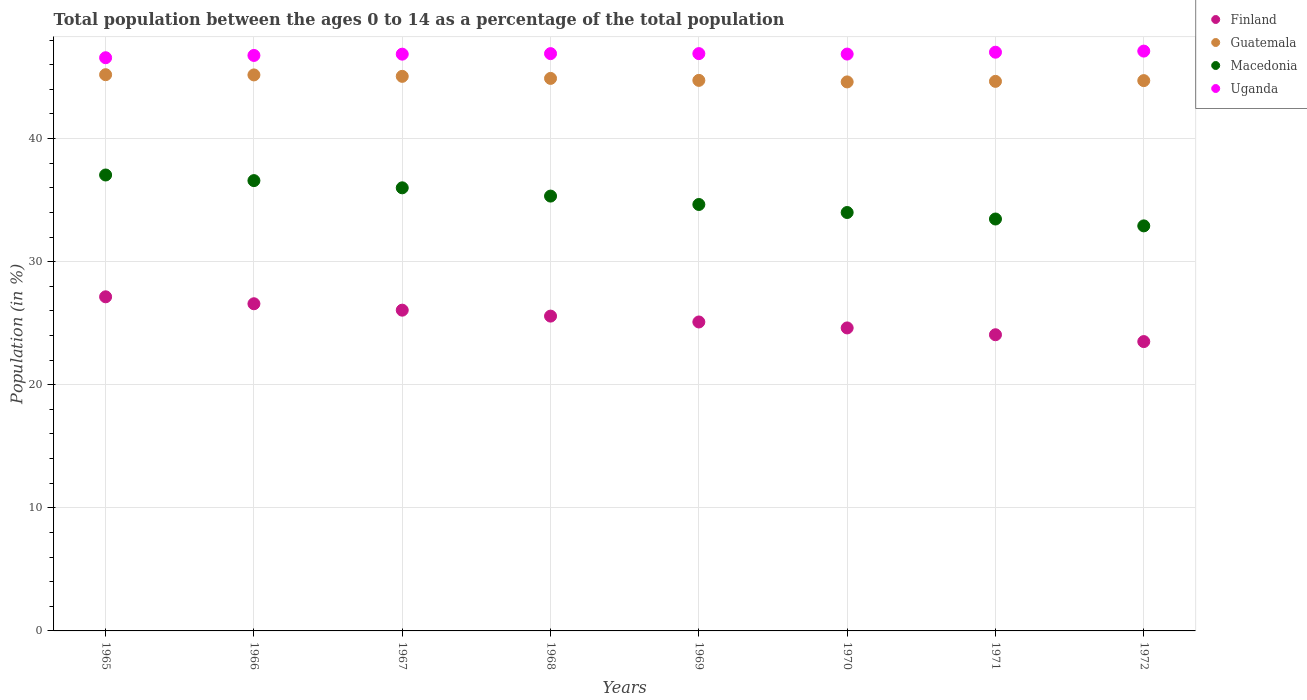How many different coloured dotlines are there?
Make the answer very short. 4. Is the number of dotlines equal to the number of legend labels?
Offer a very short reply. Yes. What is the percentage of the population ages 0 to 14 in Guatemala in 1971?
Offer a terse response. 44.65. Across all years, what is the maximum percentage of the population ages 0 to 14 in Uganda?
Your answer should be very brief. 47.11. Across all years, what is the minimum percentage of the population ages 0 to 14 in Macedonia?
Your answer should be compact. 32.91. In which year was the percentage of the population ages 0 to 14 in Guatemala maximum?
Your answer should be very brief. 1965. What is the total percentage of the population ages 0 to 14 in Guatemala in the graph?
Offer a terse response. 359.01. What is the difference between the percentage of the population ages 0 to 14 in Uganda in 1968 and that in 1972?
Provide a short and direct response. -0.21. What is the difference between the percentage of the population ages 0 to 14 in Macedonia in 1969 and the percentage of the population ages 0 to 14 in Guatemala in 1967?
Your answer should be very brief. -10.41. What is the average percentage of the population ages 0 to 14 in Finland per year?
Keep it short and to the point. 25.33. In the year 1971, what is the difference between the percentage of the population ages 0 to 14 in Macedonia and percentage of the population ages 0 to 14 in Finland?
Offer a very short reply. 9.4. What is the ratio of the percentage of the population ages 0 to 14 in Guatemala in 1970 to that in 1972?
Offer a terse response. 1. Is the percentage of the population ages 0 to 14 in Guatemala in 1969 less than that in 1970?
Your answer should be compact. No. What is the difference between the highest and the second highest percentage of the population ages 0 to 14 in Finland?
Offer a terse response. 0.56. What is the difference between the highest and the lowest percentage of the population ages 0 to 14 in Guatemala?
Your answer should be compact. 0.59. In how many years, is the percentage of the population ages 0 to 14 in Finland greater than the average percentage of the population ages 0 to 14 in Finland taken over all years?
Make the answer very short. 4. Is it the case that in every year, the sum of the percentage of the population ages 0 to 14 in Guatemala and percentage of the population ages 0 to 14 in Uganda  is greater than the sum of percentage of the population ages 0 to 14 in Macedonia and percentage of the population ages 0 to 14 in Finland?
Your response must be concise. Yes. Is it the case that in every year, the sum of the percentage of the population ages 0 to 14 in Macedonia and percentage of the population ages 0 to 14 in Uganda  is greater than the percentage of the population ages 0 to 14 in Guatemala?
Offer a very short reply. Yes. Does the percentage of the population ages 0 to 14 in Guatemala monotonically increase over the years?
Your answer should be compact. No. Is the percentage of the population ages 0 to 14 in Guatemala strictly greater than the percentage of the population ages 0 to 14 in Macedonia over the years?
Your answer should be compact. Yes. Is the percentage of the population ages 0 to 14 in Finland strictly less than the percentage of the population ages 0 to 14 in Macedonia over the years?
Give a very brief answer. Yes. Does the graph contain any zero values?
Your answer should be compact. No. Does the graph contain grids?
Make the answer very short. Yes. What is the title of the graph?
Make the answer very short. Total population between the ages 0 to 14 as a percentage of the total population. Does "Argentina" appear as one of the legend labels in the graph?
Offer a very short reply. No. What is the label or title of the X-axis?
Ensure brevity in your answer.  Years. What is the Population (in %) of Finland in 1965?
Offer a terse response. 27.15. What is the Population (in %) of Guatemala in 1965?
Keep it short and to the point. 45.19. What is the Population (in %) in Macedonia in 1965?
Your answer should be compact. 37.04. What is the Population (in %) of Uganda in 1965?
Make the answer very short. 46.57. What is the Population (in %) of Finland in 1966?
Keep it short and to the point. 26.58. What is the Population (in %) of Guatemala in 1966?
Provide a succinct answer. 45.17. What is the Population (in %) of Macedonia in 1966?
Offer a very short reply. 36.59. What is the Population (in %) of Uganda in 1966?
Make the answer very short. 46.76. What is the Population (in %) in Finland in 1967?
Provide a short and direct response. 26.06. What is the Population (in %) of Guatemala in 1967?
Offer a terse response. 45.06. What is the Population (in %) in Macedonia in 1967?
Offer a very short reply. 36. What is the Population (in %) in Uganda in 1967?
Make the answer very short. 46.86. What is the Population (in %) of Finland in 1968?
Offer a very short reply. 25.58. What is the Population (in %) in Guatemala in 1968?
Your response must be concise. 44.89. What is the Population (in %) of Macedonia in 1968?
Make the answer very short. 35.33. What is the Population (in %) in Uganda in 1968?
Give a very brief answer. 46.9. What is the Population (in %) in Finland in 1969?
Offer a very short reply. 25.1. What is the Population (in %) of Guatemala in 1969?
Ensure brevity in your answer.  44.73. What is the Population (in %) of Macedonia in 1969?
Make the answer very short. 34.65. What is the Population (in %) of Uganda in 1969?
Your answer should be compact. 46.9. What is the Population (in %) of Finland in 1970?
Your response must be concise. 24.62. What is the Population (in %) in Guatemala in 1970?
Ensure brevity in your answer.  44.6. What is the Population (in %) in Macedonia in 1970?
Your answer should be very brief. 33.99. What is the Population (in %) of Uganda in 1970?
Provide a short and direct response. 46.87. What is the Population (in %) in Finland in 1971?
Provide a succinct answer. 24.06. What is the Population (in %) of Guatemala in 1971?
Keep it short and to the point. 44.65. What is the Population (in %) in Macedonia in 1971?
Your response must be concise. 33.47. What is the Population (in %) of Uganda in 1971?
Keep it short and to the point. 47.02. What is the Population (in %) of Finland in 1972?
Keep it short and to the point. 23.51. What is the Population (in %) of Guatemala in 1972?
Give a very brief answer. 44.71. What is the Population (in %) in Macedonia in 1972?
Keep it short and to the point. 32.91. What is the Population (in %) of Uganda in 1972?
Your answer should be very brief. 47.11. Across all years, what is the maximum Population (in %) of Finland?
Ensure brevity in your answer.  27.15. Across all years, what is the maximum Population (in %) in Guatemala?
Offer a very short reply. 45.19. Across all years, what is the maximum Population (in %) in Macedonia?
Keep it short and to the point. 37.04. Across all years, what is the maximum Population (in %) in Uganda?
Make the answer very short. 47.11. Across all years, what is the minimum Population (in %) of Finland?
Your response must be concise. 23.51. Across all years, what is the minimum Population (in %) in Guatemala?
Offer a terse response. 44.6. Across all years, what is the minimum Population (in %) of Macedonia?
Give a very brief answer. 32.91. Across all years, what is the minimum Population (in %) in Uganda?
Offer a terse response. 46.57. What is the total Population (in %) of Finland in the graph?
Keep it short and to the point. 202.65. What is the total Population (in %) of Guatemala in the graph?
Your answer should be very brief. 359.01. What is the total Population (in %) of Macedonia in the graph?
Give a very brief answer. 279.97. What is the total Population (in %) of Uganda in the graph?
Give a very brief answer. 374.99. What is the difference between the Population (in %) in Finland in 1965 and that in 1966?
Give a very brief answer. 0.56. What is the difference between the Population (in %) in Guatemala in 1965 and that in 1966?
Your response must be concise. 0.02. What is the difference between the Population (in %) in Macedonia in 1965 and that in 1966?
Offer a terse response. 0.46. What is the difference between the Population (in %) of Uganda in 1965 and that in 1966?
Your response must be concise. -0.19. What is the difference between the Population (in %) of Finland in 1965 and that in 1967?
Your answer should be compact. 1.09. What is the difference between the Population (in %) in Guatemala in 1965 and that in 1967?
Ensure brevity in your answer.  0.13. What is the difference between the Population (in %) of Macedonia in 1965 and that in 1967?
Ensure brevity in your answer.  1.04. What is the difference between the Population (in %) in Uganda in 1965 and that in 1967?
Offer a very short reply. -0.29. What is the difference between the Population (in %) in Finland in 1965 and that in 1968?
Provide a short and direct response. 1.57. What is the difference between the Population (in %) of Guatemala in 1965 and that in 1968?
Your answer should be very brief. 0.3. What is the difference between the Population (in %) of Macedonia in 1965 and that in 1968?
Offer a very short reply. 1.71. What is the difference between the Population (in %) in Uganda in 1965 and that in 1968?
Your answer should be compact. -0.33. What is the difference between the Population (in %) in Finland in 1965 and that in 1969?
Make the answer very short. 2.04. What is the difference between the Population (in %) in Guatemala in 1965 and that in 1969?
Your answer should be very brief. 0.46. What is the difference between the Population (in %) in Macedonia in 1965 and that in 1969?
Provide a short and direct response. 2.4. What is the difference between the Population (in %) in Uganda in 1965 and that in 1969?
Your response must be concise. -0.33. What is the difference between the Population (in %) of Finland in 1965 and that in 1970?
Make the answer very short. 2.53. What is the difference between the Population (in %) of Guatemala in 1965 and that in 1970?
Provide a succinct answer. 0.59. What is the difference between the Population (in %) of Macedonia in 1965 and that in 1970?
Offer a very short reply. 3.05. What is the difference between the Population (in %) of Uganda in 1965 and that in 1970?
Provide a short and direct response. -0.3. What is the difference between the Population (in %) of Finland in 1965 and that in 1971?
Offer a terse response. 3.08. What is the difference between the Population (in %) in Guatemala in 1965 and that in 1971?
Your answer should be very brief. 0.54. What is the difference between the Population (in %) of Macedonia in 1965 and that in 1971?
Your response must be concise. 3.58. What is the difference between the Population (in %) of Uganda in 1965 and that in 1971?
Give a very brief answer. -0.45. What is the difference between the Population (in %) in Finland in 1965 and that in 1972?
Your answer should be compact. 3.64. What is the difference between the Population (in %) in Guatemala in 1965 and that in 1972?
Provide a short and direct response. 0.48. What is the difference between the Population (in %) in Macedonia in 1965 and that in 1972?
Your response must be concise. 4.13. What is the difference between the Population (in %) in Uganda in 1965 and that in 1972?
Provide a short and direct response. -0.54. What is the difference between the Population (in %) in Finland in 1966 and that in 1967?
Ensure brevity in your answer.  0.52. What is the difference between the Population (in %) of Guatemala in 1966 and that in 1967?
Your answer should be compact. 0.12. What is the difference between the Population (in %) in Macedonia in 1966 and that in 1967?
Ensure brevity in your answer.  0.59. What is the difference between the Population (in %) in Uganda in 1966 and that in 1967?
Keep it short and to the point. -0.1. What is the difference between the Population (in %) in Finland in 1966 and that in 1968?
Your response must be concise. 1. What is the difference between the Population (in %) in Guatemala in 1966 and that in 1968?
Your answer should be compact. 0.28. What is the difference between the Population (in %) in Macedonia in 1966 and that in 1968?
Ensure brevity in your answer.  1.26. What is the difference between the Population (in %) of Uganda in 1966 and that in 1968?
Your response must be concise. -0.15. What is the difference between the Population (in %) in Finland in 1966 and that in 1969?
Keep it short and to the point. 1.48. What is the difference between the Population (in %) of Guatemala in 1966 and that in 1969?
Your answer should be very brief. 0.44. What is the difference between the Population (in %) in Macedonia in 1966 and that in 1969?
Make the answer very short. 1.94. What is the difference between the Population (in %) of Uganda in 1966 and that in 1969?
Give a very brief answer. -0.15. What is the difference between the Population (in %) in Finland in 1966 and that in 1970?
Offer a very short reply. 1.96. What is the difference between the Population (in %) in Guatemala in 1966 and that in 1970?
Provide a succinct answer. 0.57. What is the difference between the Population (in %) of Macedonia in 1966 and that in 1970?
Provide a succinct answer. 2.59. What is the difference between the Population (in %) of Uganda in 1966 and that in 1970?
Provide a short and direct response. -0.11. What is the difference between the Population (in %) in Finland in 1966 and that in 1971?
Provide a short and direct response. 2.52. What is the difference between the Population (in %) of Guatemala in 1966 and that in 1971?
Make the answer very short. 0.52. What is the difference between the Population (in %) in Macedonia in 1966 and that in 1971?
Your answer should be compact. 3.12. What is the difference between the Population (in %) in Uganda in 1966 and that in 1971?
Keep it short and to the point. -0.26. What is the difference between the Population (in %) in Finland in 1966 and that in 1972?
Give a very brief answer. 3.07. What is the difference between the Population (in %) of Guatemala in 1966 and that in 1972?
Provide a succinct answer. 0.46. What is the difference between the Population (in %) in Macedonia in 1966 and that in 1972?
Make the answer very short. 3.68. What is the difference between the Population (in %) in Uganda in 1966 and that in 1972?
Ensure brevity in your answer.  -0.35. What is the difference between the Population (in %) of Finland in 1967 and that in 1968?
Keep it short and to the point. 0.48. What is the difference between the Population (in %) of Guatemala in 1967 and that in 1968?
Ensure brevity in your answer.  0.17. What is the difference between the Population (in %) in Macedonia in 1967 and that in 1968?
Ensure brevity in your answer.  0.67. What is the difference between the Population (in %) in Uganda in 1967 and that in 1968?
Ensure brevity in your answer.  -0.04. What is the difference between the Population (in %) of Finland in 1967 and that in 1969?
Give a very brief answer. 0.96. What is the difference between the Population (in %) in Guatemala in 1967 and that in 1969?
Offer a terse response. 0.33. What is the difference between the Population (in %) of Macedonia in 1967 and that in 1969?
Provide a succinct answer. 1.35. What is the difference between the Population (in %) of Uganda in 1967 and that in 1969?
Provide a succinct answer. -0.04. What is the difference between the Population (in %) in Finland in 1967 and that in 1970?
Provide a short and direct response. 1.44. What is the difference between the Population (in %) of Guatemala in 1967 and that in 1970?
Your answer should be very brief. 0.45. What is the difference between the Population (in %) in Macedonia in 1967 and that in 1970?
Offer a terse response. 2.01. What is the difference between the Population (in %) in Uganda in 1967 and that in 1970?
Your answer should be very brief. -0.01. What is the difference between the Population (in %) of Finland in 1967 and that in 1971?
Offer a terse response. 2. What is the difference between the Population (in %) in Guatemala in 1967 and that in 1971?
Offer a terse response. 0.41. What is the difference between the Population (in %) in Macedonia in 1967 and that in 1971?
Offer a very short reply. 2.53. What is the difference between the Population (in %) in Uganda in 1967 and that in 1971?
Your response must be concise. -0.16. What is the difference between the Population (in %) in Finland in 1967 and that in 1972?
Provide a succinct answer. 2.55. What is the difference between the Population (in %) in Guatemala in 1967 and that in 1972?
Ensure brevity in your answer.  0.35. What is the difference between the Population (in %) of Macedonia in 1967 and that in 1972?
Make the answer very short. 3.09. What is the difference between the Population (in %) in Uganda in 1967 and that in 1972?
Ensure brevity in your answer.  -0.25. What is the difference between the Population (in %) of Finland in 1968 and that in 1969?
Keep it short and to the point. 0.48. What is the difference between the Population (in %) in Guatemala in 1968 and that in 1969?
Keep it short and to the point. 0.16. What is the difference between the Population (in %) of Macedonia in 1968 and that in 1969?
Provide a short and direct response. 0.68. What is the difference between the Population (in %) in Uganda in 1968 and that in 1969?
Your answer should be compact. -0. What is the difference between the Population (in %) of Finland in 1968 and that in 1970?
Your answer should be very brief. 0.96. What is the difference between the Population (in %) in Guatemala in 1968 and that in 1970?
Make the answer very short. 0.29. What is the difference between the Population (in %) of Macedonia in 1968 and that in 1970?
Provide a succinct answer. 1.33. What is the difference between the Population (in %) in Uganda in 1968 and that in 1970?
Offer a terse response. 0.04. What is the difference between the Population (in %) in Finland in 1968 and that in 1971?
Provide a succinct answer. 1.51. What is the difference between the Population (in %) in Guatemala in 1968 and that in 1971?
Your answer should be very brief. 0.24. What is the difference between the Population (in %) in Macedonia in 1968 and that in 1971?
Offer a terse response. 1.86. What is the difference between the Population (in %) in Uganda in 1968 and that in 1971?
Provide a succinct answer. -0.12. What is the difference between the Population (in %) in Finland in 1968 and that in 1972?
Provide a short and direct response. 2.07. What is the difference between the Population (in %) in Guatemala in 1968 and that in 1972?
Provide a short and direct response. 0.18. What is the difference between the Population (in %) of Macedonia in 1968 and that in 1972?
Offer a terse response. 2.42. What is the difference between the Population (in %) of Uganda in 1968 and that in 1972?
Provide a short and direct response. -0.21. What is the difference between the Population (in %) in Finland in 1969 and that in 1970?
Offer a terse response. 0.48. What is the difference between the Population (in %) of Guatemala in 1969 and that in 1970?
Give a very brief answer. 0.13. What is the difference between the Population (in %) in Macedonia in 1969 and that in 1970?
Your response must be concise. 0.65. What is the difference between the Population (in %) of Uganda in 1969 and that in 1970?
Provide a short and direct response. 0.04. What is the difference between the Population (in %) in Finland in 1969 and that in 1971?
Keep it short and to the point. 1.04. What is the difference between the Population (in %) of Guatemala in 1969 and that in 1971?
Ensure brevity in your answer.  0.08. What is the difference between the Population (in %) of Macedonia in 1969 and that in 1971?
Your response must be concise. 1.18. What is the difference between the Population (in %) in Uganda in 1969 and that in 1971?
Give a very brief answer. -0.11. What is the difference between the Population (in %) of Finland in 1969 and that in 1972?
Offer a terse response. 1.59. What is the difference between the Population (in %) of Guatemala in 1969 and that in 1972?
Offer a terse response. 0.02. What is the difference between the Population (in %) of Macedonia in 1969 and that in 1972?
Your answer should be compact. 1.74. What is the difference between the Population (in %) in Uganda in 1969 and that in 1972?
Ensure brevity in your answer.  -0.2. What is the difference between the Population (in %) in Finland in 1970 and that in 1971?
Keep it short and to the point. 0.55. What is the difference between the Population (in %) in Guatemala in 1970 and that in 1971?
Provide a short and direct response. -0.05. What is the difference between the Population (in %) of Macedonia in 1970 and that in 1971?
Your answer should be compact. 0.53. What is the difference between the Population (in %) of Uganda in 1970 and that in 1971?
Give a very brief answer. -0.15. What is the difference between the Population (in %) of Finland in 1970 and that in 1972?
Your answer should be very brief. 1.11. What is the difference between the Population (in %) of Guatemala in 1970 and that in 1972?
Ensure brevity in your answer.  -0.11. What is the difference between the Population (in %) of Macedonia in 1970 and that in 1972?
Ensure brevity in your answer.  1.09. What is the difference between the Population (in %) of Uganda in 1970 and that in 1972?
Make the answer very short. -0.24. What is the difference between the Population (in %) in Finland in 1971 and that in 1972?
Ensure brevity in your answer.  0.56. What is the difference between the Population (in %) in Guatemala in 1971 and that in 1972?
Keep it short and to the point. -0.06. What is the difference between the Population (in %) of Macedonia in 1971 and that in 1972?
Give a very brief answer. 0.56. What is the difference between the Population (in %) of Uganda in 1971 and that in 1972?
Provide a short and direct response. -0.09. What is the difference between the Population (in %) in Finland in 1965 and the Population (in %) in Guatemala in 1966?
Provide a succinct answer. -18.03. What is the difference between the Population (in %) in Finland in 1965 and the Population (in %) in Macedonia in 1966?
Provide a succinct answer. -9.44. What is the difference between the Population (in %) of Finland in 1965 and the Population (in %) of Uganda in 1966?
Your response must be concise. -19.61. What is the difference between the Population (in %) of Guatemala in 1965 and the Population (in %) of Macedonia in 1966?
Offer a terse response. 8.61. What is the difference between the Population (in %) in Guatemala in 1965 and the Population (in %) in Uganda in 1966?
Your answer should be compact. -1.56. What is the difference between the Population (in %) in Macedonia in 1965 and the Population (in %) in Uganda in 1966?
Offer a terse response. -9.71. What is the difference between the Population (in %) in Finland in 1965 and the Population (in %) in Guatemala in 1967?
Your answer should be compact. -17.91. What is the difference between the Population (in %) of Finland in 1965 and the Population (in %) of Macedonia in 1967?
Ensure brevity in your answer.  -8.85. What is the difference between the Population (in %) in Finland in 1965 and the Population (in %) in Uganda in 1967?
Your answer should be compact. -19.71. What is the difference between the Population (in %) of Guatemala in 1965 and the Population (in %) of Macedonia in 1967?
Your response must be concise. 9.19. What is the difference between the Population (in %) of Guatemala in 1965 and the Population (in %) of Uganda in 1967?
Ensure brevity in your answer.  -1.67. What is the difference between the Population (in %) in Macedonia in 1965 and the Population (in %) in Uganda in 1967?
Your response must be concise. -9.82. What is the difference between the Population (in %) of Finland in 1965 and the Population (in %) of Guatemala in 1968?
Offer a terse response. -17.74. What is the difference between the Population (in %) of Finland in 1965 and the Population (in %) of Macedonia in 1968?
Make the answer very short. -8.18. What is the difference between the Population (in %) in Finland in 1965 and the Population (in %) in Uganda in 1968?
Ensure brevity in your answer.  -19.76. What is the difference between the Population (in %) of Guatemala in 1965 and the Population (in %) of Macedonia in 1968?
Offer a terse response. 9.86. What is the difference between the Population (in %) of Guatemala in 1965 and the Population (in %) of Uganda in 1968?
Your answer should be very brief. -1.71. What is the difference between the Population (in %) in Macedonia in 1965 and the Population (in %) in Uganda in 1968?
Give a very brief answer. -9.86. What is the difference between the Population (in %) of Finland in 1965 and the Population (in %) of Guatemala in 1969?
Keep it short and to the point. -17.58. What is the difference between the Population (in %) of Finland in 1965 and the Population (in %) of Macedonia in 1969?
Keep it short and to the point. -7.5. What is the difference between the Population (in %) of Finland in 1965 and the Population (in %) of Uganda in 1969?
Provide a succinct answer. -19.76. What is the difference between the Population (in %) in Guatemala in 1965 and the Population (in %) in Macedonia in 1969?
Provide a succinct answer. 10.54. What is the difference between the Population (in %) in Guatemala in 1965 and the Population (in %) in Uganda in 1969?
Provide a succinct answer. -1.71. What is the difference between the Population (in %) of Macedonia in 1965 and the Population (in %) of Uganda in 1969?
Give a very brief answer. -9.86. What is the difference between the Population (in %) of Finland in 1965 and the Population (in %) of Guatemala in 1970?
Offer a terse response. -17.46. What is the difference between the Population (in %) of Finland in 1965 and the Population (in %) of Macedonia in 1970?
Give a very brief answer. -6.85. What is the difference between the Population (in %) in Finland in 1965 and the Population (in %) in Uganda in 1970?
Ensure brevity in your answer.  -19.72. What is the difference between the Population (in %) in Guatemala in 1965 and the Population (in %) in Macedonia in 1970?
Give a very brief answer. 11.2. What is the difference between the Population (in %) in Guatemala in 1965 and the Population (in %) in Uganda in 1970?
Provide a succinct answer. -1.68. What is the difference between the Population (in %) of Macedonia in 1965 and the Population (in %) of Uganda in 1970?
Keep it short and to the point. -9.82. What is the difference between the Population (in %) in Finland in 1965 and the Population (in %) in Guatemala in 1971?
Provide a short and direct response. -17.5. What is the difference between the Population (in %) in Finland in 1965 and the Population (in %) in Macedonia in 1971?
Offer a terse response. -6.32. What is the difference between the Population (in %) of Finland in 1965 and the Population (in %) of Uganda in 1971?
Offer a very short reply. -19.87. What is the difference between the Population (in %) of Guatemala in 1965 and the Population (in %) of Macedonia in 1971?
Provide a succinct answer. 11.72. What is the difference between the Population (in %) in Guatemala in 1965 and the Population (in %) in Uganda in 1971?
Offer a very short reply. -1.83. What is the difference between the Population (in %) in Macedonia in 1965 and the Population (in %) in Uganda in 1971?
Your response must be concise. -9.98. What is the difference between the Population (in %) in Finland in 1965 and the Population (in %) in Guatemala in 1972?
Offer a terse response. -17.57. What is the difference between the Population (in %) in Finland in 1965 and the Population (in %) in Macedonia in 1972?
Your response must be concise. -5.76. What is the difference between the Population (in %) in Finland in 1965 and the Population (in %) in Uganda in 1972?
Provide a succinct answer. -19.96. What is the difference between the Population (in %) of Guatemala in 1965 and the Population (in %) of Macedonia in 1972?
Make the answer very short. 12.28. What is the difference between the Population (in %) in Guatemala in 1965 and the Population (in %) in Uganda in 1972?
Ensure brevity in your answer.  -1.92. What is the difference between the Population (in %) of Macedonia in 1965 and the Population (in %) of Uganda in 1972?
Provide a succinct answer. -10.07. What is the difference between the Population (in %) in Finland in 1966 and the Population (in %) in Guatemala in 1967?
Offer a very short reply. -18.48. What is the difference between the Population (in %) in Finland in 1966 and the Population (in %) in Macedonia in 1967?
Make the answer very short. -9.42. What is the difference between the Population (in %) in Finland in 1966 and the Population (in %) in Uganda in 1967?
Ensure brevity in your answer.  -20.28. What is the difference between the Population (in %) in Guatemala in 1966 and the Population (in %) in Macedonia in 1967?
Make the answer very short. 9.17. What is the difference between the Population (in %) in Guatemala in 1966 and the Population (in %) in Uganda in 1967?
Make the answer very short. -1.69. What is the difference between the Population (in %) of Macedonia in 1966 and the Population (in %) of Uganda in 1967?
Keep it short and to the point. -10.27. What is the difference between the Population (in %) of Finland in 1966 and the Population (in %) of Guatemala in 1968?
Provide a succinct answer. -18.31. What is the difference between the Population (in %) of Finland in 1966 and the Population (in %) of Macedonia in 1968?
Offer a very short reply. -8.75. What is the difference between the Population (in %) in Finland in 1966 and the Population (in %) in Uganda in 1968?
Your answer should be very brief. -20.32. What is the difference between the Population (in %) in Guatemala in 1966 and the Population (in %) in Macedonia in 1968?
Provide a succinct answer. 9.84. What is the difference between the Population (in %) in Guatemala in 1966 and the Population (in %) in Uganda in 1968?
Your answer should be very brief. -1.73. What is the difference between the Population (in %) in Macedonia in 1966 and the Population (in %) in Uganda in 1968?
Offer a very short reply. -10.32. What is the difference between the Population (in %) in Finland in 1966 and the Population (in %) in Guatemala in 1969?
Your answer should be very brief. -18.15. What is the difference between the Population (in %) of Finland in 1966 and the Population (in %) of Macedonia in 1969?
Offer a terse response. -8.07. What is the difference between the Population (in %) of Finland in 1966 and the Population (in %) of Uganda in 1969?
Your answer should be very brief. -20.32. What is the difference between the Population (in %) of Guatemala in 1966 and the Population (in %) of Macedonia in 1969?
Offer a very short reply. 10.53. What is the difference between the Population (in %) in Guatemala in 1966 and the Population (in %) in Uganda in 1969?
Provide a short and direct response. -1.73. What is the difference between the Population (in %) of Macedonia in 1966 and the Population (in %) of Uganda in 1969?
Offer a very short reply. -10.32. What is the difference between the Population (in %) of Finland in 1966 and the Population (in %) of Guatemala in 1970?
Your answer should be compact. -18.02. What is the difference between the Population (in %) in Finland in 1966 and the Population (in %) in Macedonia in 1970?
Make the answer very short. -7.41. What is the difference between the Population (in %) in Finland in 1966 and the Population (in %) in Uganda in 1970?
Offer a very short reply. -20.29. What is the difference between the Population (in %) of Guatemala in 1966 and the Population (in %) of Macedonia in 1970?
Ensure brevity in your answer.  11.18. What is the difference between the Population (in %) of Guatemala in 1966 and the Population (in %) of Uganda in 1970?
Give a very brief answer. -1.69. What is the difference between the Population (in %) in Macedonia in 1966 and the Population (in %) in Uganda in 1970?
Give a very brief answer. -10.28. What is the difference between the Population (in %) in Finland in 1966 and the Population (in %) in Guatemala in 1971?
Your answer should be very brief. -18.07. What is the difference between the Population (in %) of Finland in 1966 and the Population (in %) of Macedonia in 1971?
Provide a short and direct response. -6.89. What is the difference between the Population (in %) in Finland in 1966 and the Population (in %) in Uganda in 1971?
Your answer should be compact. -20.44. What is the difference between the Population (in %) in Guatemala in 1966 and the Population (in %) in Macedonia in 1971?
Ensure brevity in your answer.  11.71. What is the difference between the Population (in %) in Guatemala in 1966 and the Population (in %) in Uganda in 1971?
Provide a short and direct response. -1.85. What is the difference between the Population (in %) of Macedonia in 1966 and the Population (in %) of Uganda in 1971?
Provide a succinct answer. -10.43. What is the difference between the Population (in %) in Finland in 1966 and the Population (in %) in Guatemala in 1972?
Offer a very short reply. -18.13. What is the difference between the Population (in %) in Finland in 1966 and the Population (in %) in Macedonia in 1972?
Ensure brevity in your answer.  -6.33. What is the difference between the Population (in %) of Finland in 1966 and the Population (in %) of Uganda in 1972?
Your answer should be compact. -20.53. What is the difference between the Population (in %) of Guatemala in 1966 and the Population (in %) of Macedonia in 1972?
Ensure brevity in your answer.  12.27. What is the difference between the Population (in %) of Guatemala in 1966 and the Population (in %) of Uganda in 1972?
Provide a short and direct response. -1.94. What is the difference between the Population (in %) in Macedonia in 1966 and the Population (in %) in Uganda in 1972?
Make the answer very short. -10.52. What is the difference between the Population (in %) in Finland in 1967 and the Population (in %) in Guatemala in 1968?
Ensure brevity in your answer.  -18.83. What is the difference between the Population (in %) of Finland in 1967 and the Population (in %) of Macedonia in 1968?
Your answer should be compact. -9.27. What is the difference between the Population (in %) of Finland in 1967 and the Population (in %) of Uganda in 1968?
Ensure brevity in your answer.  -20.84. What is the difference between the Population (in %) in Guatemala in 1967 and the Population (in %) in Macedonia in 1968?
Offer a terse response. 9.73. What is the difference between the Population (in %) in Guatemala in 1967 and the Population (in %) in Uganda in 1968?
Your answer should be compact. -1.85. What is the difference between the Population (in %) of Macedonia in 1967 and the Population (in %) of Uganda in 1968?
Your response must be concise. -10.9. What is the difference between the Population (in %) of Finland in 1967 and the Population (in %) of Guatemala in 1969?
Your answer should be very brief. -18.67. What is the difference between the Population (in %) of Finland in 1967 and the Population (in %) of Macedonia in 1969?
Provide a succinct answer. -8.59. What is the difference between the Population (in %) of Finland in 1967 and the Population (in %) of Uganda in 1969?
Ensure brevity in your answer.  -20.84. What is the difference between the Population (in %) of Guatemala in 1967 and the Population (in %) of Macedonia in 1969?
Your response must be concise. 10.41. What is the difference between the Population (in %) of Guatemala in 1967 and the Population (in %) of Uganda in 1969?
Provide a succinct answer. -1.85. What is the difference between the Population (in %) in Macedonia in 1967 and the Population (in %) in Uganda in 1969?
Your response must be concise. -10.9. What is the difference between the Population (in %) of Finland in 1967 and the Population (in %) of Guatemala in 1970?
Offer a terse response. -18.54. What is the difference between the Population (in %) of Finland in 1967 and the Population (in %) of Macedonia in 1970?
Offer a very short reply. -7.93. What is the difference between the Population (in %) of Finland in 1967 and the Population (in %) of Uganda in 1970?
Offer a terse response. -20.81. What is the difference between the Population (in %) of Guatemala in 1967 and the Population (in %) of Macedonia in 1970?
Make the answer very short. 11.06. What is the difference between the Population (in %) in Guatemala in 1967 and the Population (in %) in Uganda in 1970?
Give a very brief answer. -1.81. What is the difference between the Population (in %) in Macedonia in 1967 and the Population (in %) in Uganda in 1970?
Keep it short and to the point. -10.87. What is the difference between the Population (in %) of Finland in 1967 and the Population (in %) of Guatemala in 1971?
Ensure brevity in your answer.  -18.59. What is the difference between the Population (in %) of Finland in 1967 and the Population (in %) of Macedonia in 1971?
Keep it short and to the point. -7.41. What is the difference between the Population (in %) in Finland in 1967 and the Population (in %) in Uganda in 1971?
Provide a short and direct response. -20.96. What is the difference between the Population (in %) in Guatemala in 1967 and the Population (in %) in Macedonia in 1971?
Provide a short and direct response. 11.59. What is the difference between the Population (in %) of Guatemala in 1967 and the Population (in %) of Uganda in 1971?
Offer a terse response. -1.96. What is the difference between the Population (in %) in Macedonia in 1967 and the Population (in %) in Uganda in 1971?
Provide a succinct answer. -11.02. What is the difference between the Population (in %) of Finland in 1967 and the Population (in %) of Guatemala in 1972?
Your answer should be very brief. -18.65. What is the difference between the Population (in %) in Finland in 1967 and the Population (in %) in Macedonia in 1972?
Your answer should be compact. -6.85. What is the difference between the Population (in %) of Finland in 1967 and the Population (in %) of Uganda in 1972?
Ensure brevity in your answer.  -21.05. What is the difference between the Population (in %) in Guatemala in 1967 and the Population (in %) in Macedonia in 1972?
Your answer should be compact. 12.15. What is the difference between the Population (in %) in Guatemala in 1967 and the Population (in %) in Uganda in 1972?
Offer a terse response. -2.05. What is the difference between the Population (in %) of Macedonia in 1967 and the Population (in %) of Uganda in 1972?
Ensure brevity in your answer.  -11.11. What is the difference between the Population (in %) of Finland in 1968 and the Population (in %) of Guatemala in 1969?
Your answer should be compact. -19.15. What is the difference between the Population (in %) of Finland in 1968 and the Population (in %) of Macedonia in 1969?
Provide a short and direct response. -9.07. What is the difference between the Population (in %) of Finland in 1968 and the Population (in %) of Uganda in 1969?
Your answer should be compact. -21.33. What is the difference between the Population (in %) in Guatemala in 1968 and the Population (in %) in Macedonia in 1969?
Ensure brevity in your answer.  10.24. What is the difference between the Population (in %) of Guatemala in 1968 and the Population (in %) of Uganda in 1969?
Your answer should be very brief. -2.01. What is the difference between the Population (in %) in Macedonia in 1968 and the Population (in %) in Uganda in 1969?
Your answer should be compact. -11.58. What is the difference between the Population (in %) in Finland in 1968 and the Population (in %) in Guatemala in 1970?
Give a very brief answer. -19.03. What is the difference between the Population (in %) in Finland in 1968 and the Population (in %) in Macedonia in 1970?
Ensure brevity in your answer.  -8.42. What is the difference between the Population (in %) of Finland in 1968 and the Population (in %) of Uganda in 1970?
Provide a short and direct response. -21.29. What is the difference between the Population (in %) of Guatemala in 1968 and the Population (in %) of Macedonia in 1970?
Make the answer very short. 10.9. What is the difference between the Population (in %) of Guatemala in 1968 and the Population (in %) of Uganda in 1970?
Provide a short and direct response. -1.98. What is the difference between the Population (in %) of Macedonia in 1968 and the Population (in %) of Uganda in 1970?
Offer a very short reply. -11.54. What is the difference between the Population (in %) of Finland in 1968 and the Population (in %) of Guatemala in 1971?
Keep it short and to the point. -19.07. What is the difference between the Population (in %) of Finland in 1968 and the Population (in %) of Macedonia in 1971?
Ensure brevity in your answer.  -7.89. What is the difference between the Population (in %) of Finland in 1968 and the Population (in %) of Uganda in 1971?
Your response must be concise. -21.44. What is the difference between the Population (in %) of Guatemala in 1968 and the Population (in %) of Macedonia in 1971?
Keep it short and to the point. 11.42. What is the difference between the Population (in %) of Guatemala in 1968 and the Population (in %) of Uganda in 1971?
Give a very brief answer. -2.13. What is the difference between the Population (in %) in Macedonia in 1968 and the Population (in %) in Uganda in 1971?
Offer a terse response. -11.69. What is the difference between the Population (in %) in Finland in 1968 and the Population (in %) in Guatemala in 1972?
Ensure brevity in your answer.  -19.13. What is the difference between the Population (in %) of Finland in 1968 and the Population (in %) of Macedonia in 1972?
Provide a succinct answer. -7.33. What is the difference between the Population (in %) of Finland in 1968 and the Population (in %) of Uganda in 1972?
Ensure brevity in your answer.  -21.53. What is the difference between the Population (in %) in Guatemala in 1968 and the Population (in %) in Macedonia in 1972?
Your answer should be compact. 11.98. What is the difference between the Population (in %) of Guatemala in 1968 and the Population (in %) of Uganda in 1972?
Provide a succinct answer. -2.22. What is the difference between the Population (in %) of Macedonia in 1968 and the Population (in %) of Uganda in 1972?
Provide a short and direct response. -11.78. What is the difference between the Population (in %) in Finland in 1969 and the Population (in %) in Guatemala in 1970?
Provide a succinct answer. -19.5. What is the difference between the Population (in %) in Finland in 1969 and the Population (in %) in Macedonia in 1970?
Make the answer very short. -8.89. What is the difference between the Population (in %) of Finland in 1969 and the Population (in %) of Uganda in 1970?
Ensure brevity in your answer.  -21.77. What is the difference between the Population (in %) in Guatemala in 1969 and the Population (in %) in Macedonia in 1970?
Your response must be concise. 10.73. What is the difference between the Population (in %) of Guatemala in 1969 and the Population (in %) of Uganda in 1970?
Your answer should be compact. -2.14. What is the difference between the Population (in %) of Macedonia in 1969 and the Population (in %) of Uganda in 1970?
Offer a terse response. -12.22. What is the difference between the Population (in %) in Finland in 1969 and the Population (in %) in Guatemala in 1971?
Offer a terse response. -19.55. What is the difference between the Population (in %) in Finland in 1969 and the Population (in %) in Macedonia in 1971?
Give a very brief answer. -8.37. What is the difference between the Population (in %) in Finland in 1969 and the Population (in %) in Uganda in 1971?
Your answer should be compact. -21.92. What is the difference between the Population (in %) of Guatemala in 1969 and the Population (in %) of Macedonia in 1971?
Keep it short and to the point. 11.26. What is the difference between the Population (in %) in Guatemala in 1969 and the Population (in %) in Uganda in 1971?
Your response must be concise. -2.29. What is the difference between the Population (in %) of Macedonia in 1969 and the Population (in %) of Uganda in 1971?
Offer a very short reply. -12.37. What is the difference between the Population (in %) in Finland in 1969 and the Population (in %) in Guatemala in 1972?
Offer a terse response. -19.61. What is the difference between the Population (in %) of Finland in 1969 and the Population (in %) of Macedonia in 1972?
Offer a terse response. -7.81. What is the difference between the Population (in %) of Finland in 1969 and the Population (in %) of Uganda in 1972?
Provide a short and direct response. -22.01. What is the difference between the Population (in %) in Guatemala in 1969 and the Population (in %) in Macedonia in 1972?
Offer a terse response. 11.82. What is the difference between the Population (in %) in Guatemala in 1969 and the Population (in %) in Uganda in 1972?
Your answer should be compact. -2.38. What is the difference between the Population (in %) of Macedonia in 1969 and the Population (in %) of Uganda in 1972?
Ensure brevity in your answer.  -12.46. What is the difference between the Population (in %) of Finland in 1970 and the Population (in %) of Guatemala in 1971?
Ensure brevity in your answer.  -20.03. What is the difference between the Population (in %) in Finland in 1970 and the Population (in %) in Macedonia in 1971?
Provide a succinct answer. -8.85. What is the difference between the Population (in %) of Finland in 1970 and the Population (in %) of Uganda in 1971?
Keep it short and to the point. -22.4. What is the difference between the Population (in %) of Guatemala in 1970 and the Population (in %) of Macedonia in 1971?
Offer a very short reply. 11.14. What is the difference between the Population (in %) in Guatemala in 1970 and the Population (in %) in Uganda in 1971?
Offer a terse response. -2.41. What is the difference between the Population (in %) of Macedonia in 1970 and the Population (in %) of Uganda in 1971?
Make the answer very short. -13.02. What is the difference between the Population (in %) in Finland in 1970 and the Population (in %) in Guatemala in 1972?
Your answer should be compact. -20.09. What is the difference between the Population (in %) of Finland in 1970 and the Population (in %) of Macedonia in 1972?
Offer a terse response. -8.29. What is the difference between the Population (in %) of Finland in 1970 and the Population (in %) of Uganda in 1972?
Your answer should be compact. -22.49. What is the difference between the Population (in %) in Guatemala in 1970 and the Population (in %) in Macedonia in 1972?
Offer a terse response. 11.7. What is the difference between the Population (in %) in Guatemala in 1970 and the Population (in %) in Uganda in 1972?
Your answer should be very brief. -2.5. What is the difference between the Population (in %) of Macedonia in 1970 and the Population (in %) of Uganda in 1972?
Offer a very short reply. -13.11. What is the difference between the Population (in %) of Finland in 1971 and the Population (in %) of Guatemala in 1972?
Offer a terse response. -20.65. What is the difference between the Population (in %) of Finland in 1971 and the Population (in %) of Macedonia in 1972?
Provide a succinct answer. -8.84. What is the difference between the Population (in %) in Finland in 1971 and the Population (in %) in Uganda in 1972?
Give a very brief answer. -23.05. What is the difference between the Population (in %) in Guatemala in 1971 and the Population (in %) in Macedonia in 1972?
Your response must be concise. 11.74. What is the difference between the Population (in %) of Guatemala in 1971 and the Population (in %) of Uganda in 1972?
Your response must be concise. -2.46. What is the difference between the Population (in %) in Macedonia in 1971 and the Population (in %) in Uganda in 1972?
Your response must be concise. -13.64. What is the average Population (in %) of Finland per year?
Ensure brevity in your answer.  25.33. What is the average Population (in %) of Guatemala per year?
Ensure brevity in your answer.  44.88. What is the average Population (in %) of Macedonia per year?
Your answer should be compact. 35. What is the average Population (in %) in Uganda per year?
Make the answer very short. 46.87. In the year 1965, what is the difference between the Population (in %) in Finland and Population (in %) in Guatemala?
Ensure brevity in your answer.  -18.05. In the year 1965, what is the difference between the Population (in %) in Finland and Population (in %) in Macedonia?
Ensure brevity in your answer.  -9.9. In the year 1965, what is the difference between the Population (in %) of Finland and Population (in %) of Uganda?
Keep it short and to the point. -19.42. In the year 1965, what is the difference between the Population (in %) of Guatemala and Population (in %) of Macedonia?
Your answer should be compact. 8.15. In the year 1965, what is the difference between the Population (in %) of Guatemala and Population (in %) of Uganda?
Provide a short and direct response. -1.38. In the year 1965, what is the difference between the Population (in %) in Macedonia and Population (in %) in Uganda?
Your answer should be very brief. -9.53. In the year 1966, what is the difference between the Population (in %) in Finland and Population (in %) in Guatemala?
Give a very brief answer. -18.59. In the year 1966, what is the difference between the Population (in %) in Finland and Population (in %) in Macedonia?
Give a very brief answer. -10. In the year 1966, what is the difference between the Population (in %) of Finland and Population (in %) of Uganda?
Give a very brief answer. -20.17. In the year 1966, what is the difference between the Population (in %) of Guatemala and Population (in %) of Macedonia?
Offer a terse response. 8.59. In the year 1966, what is the difference between the Population (in %) of Guatemala and Population (in %) of Uganda?
Offer a very short reply. -1.58. In the year 1966, what is the difference between the Population (in %) in Macedonia and Population (in %) in Uganda?
Keep it short and to the point. -10.17. In the year 1967, what is the difference between the Population (in %) of Finland and Population (in %) of Guatemala?
Keep it short and to the point. -19. In the year 1967, what is the difference between the Population (in %) in Finland and Population (in %) in Macedonia?
Your answer should be very brief. -9.94. In the year 1967, what is the difference between the Population (in %) of Finland and Population (in %) of Uganda?
Offer a very short reply. -20.8. In the year 1967, what is the difference between the Population (in %) in Guatemala and Population (in %) in Macedonia?
Provide a succinct answer. 9.06. In the year 1967, what is the difference between the Population (in %) in Guatemala and Population (in %) in Uganda?
Your response must be concise. -1.8. In the year 1967, what is the difference between the Population (in %) in Macedonia and Population (in %) in Uganda?
Your response must be concise. -10.86. In the year 1968, what is the difference between the Population (in %) of Finland and Population (in %) of Guatemala?
Your answer should be compact. -19.31. In the year 1968, what is the difference between the Population (in %) in Finland and Population (in %) in Macedonia?
Provide a short and direct response. -9.75. In the year 1968, what is the difference between the Population (in %) of Finland and Population (in %) of Uganda?
Make the answer very short. -21.33. In the year 1968, what is the difference between the Population (in %) in Guatemala and Population (in %) in Macedonia?
Your answer should be compact. 9.56. In the year 1968, what is the difference between the Population (in %) in Guatemala and Population (in %) in Uganda?
Give a very brief answer. -2.01. In the year 1968, what is the difference between the Population (in %) of Macedonia and Population (in %) of Uganda?
Your answer should be compact. -11.57. In the year 1969, what is the difference between the Population (in %) in Finland and Population (in %) in Guatemala?
Make the answer very short. -19.63. In the year 1969, what is the difference between the Population (in %) in Finland and Population (in %) in Macedonia?
Ensure brevity in your answer.  -9.55. In the year 1969, what is the difference between the Population (in %) in Finland and Population (in %) in Uganda?
Ensure brevity in your answer.  -21.8. In the year 1969, what is the difference between the Population (in %) in Guatemala and Population (in %) in Macedonia?
Make the answer very short. 10.08. In the year 1969, what is the difference between the Population (in %) of Guatemala and Population (in %) of Uganda?
Your answer should be compact. -2.17. In the year 1969, what is the difference between the Population (in %) in Macedonia and Population (in %) in Uganda?
Your response must be concise. -12.26. In the year 1970, what is the difference between the Population (in %) of Finland and Population (in %) of Guatemala?
Offer a terse response. -19.99. In the year 1970, what is the difference between the Population (in %) in Finland and Population (in %) in Macedonia?
Make the answer very short. -9.38. In the year 1970, what is the difference between the Population (in %) of Finland and Population (in %) of Uganda?
Your answer should be compact. -22.25. In the year 1970, what is the difference between the Population (in %) of Guatemala and Population (in %) of Macedonia?
Provide a short and direct response. 10.61. In the year 1970, what is the difference between the Population (in %) in Guatemala and Population (in %) in Uganda?
Ensure brevity in your answer.  -2.26. In the year 1970, what is the difference between the Population (in %) of Macedonia and Population (in %) of Uganda?
Keep it short and to the point. -12.87. In the year 1971, what is the difference between the Population (in %) of Finland and Population (in %) of Guatemala?
Your response must be concise. -20.59. In the year 1971, what is the difference between the Population (in %) of Finland and Population (in %) of Macedonia?
Provide a short and direct response. -9.4. In the year 1971, what is the difference between the Population (in %) in Finland and Population (in %) in Uganda?
Offer a terse response. -22.96. In the year 1971, what is the difference between the Population (in %) in Guatemala and Population (in %) in Macedonia?
Give a very brief answer. 11.18. In the year 1971, what is the difference between the Population (in %) in Guatemala and Population (in %) in Uganda?
Your answer should be compact. -2.37. In the year 1971, what is the difference between the Population (in %) of Macedonia and Population (in %) of Uganda?
Provide a short and direct response. -13.55. In the year 1972, what is the difference between the Population (in %) in Finland and Population (in %) in Guatemala?
Make the answer very short. -21.2. In the year 1972, what is the difference between the Population (in %) of Finland and Population (in %) of Uganda?
Provide a succinct answer. -23.6. In the year 1972, what is the difference between the Population (in %) of Guatemala and Population (in %) of Macedonia?
Give a very brief answer. 11.8. In the year 1972, what is the difference between the Population (in %) in Guatemala and Population (in %) in Uganda?
Offer a terse response. -2.4. In the year 1972, what is the difference between the Population (in %) of Macedonia and Population (in %) of Uganda?
Offer a terse response. -14.2. What is the ratio of the Population (in %) in Finland in 1965 to that in 1966?
Your response must be concise. 1.02. What is the ratio of the Population (in %) in Macedonia in 1965 to that in 1966?
Ensure brevity in your answer.  1.01. What is the ratio of the Population (in %) in Finland in 1965 to that in 1967?
Offer a terse response. 1.04. What is the ratio of the Population (in %) of Guatemala in 1965 to that in 1967?
Offer a terse response. 1. What is the ratio of the Population (in %) of Macedonia in 1965 to that in 1967?
Give a very brief answer. 1.03. What is the ratio of the Population (in %) of Uganda in 1965 to that in 1967?
Your answer should be very brief. 0.99. What is the ratio of the Population (in %) in Finland in 1965 to that in 1968?
Ensure brevity in your answer.  1.06. What is the ratio of the Population (in %) in Guatemala in 1965 to that in 1968?
Make the answer very short. 1.01. What is the ratio of the Population (in %) in Macedonia in 1965 to that in 1968?
Offer a very short reply. 1.05. What is the ratio of the Population (in %) in Finland in 1965 to that in 1969?
Your answer should be very brief. 1.08. What is the ratio of the Population (in %) of Guatemala in 1965 to that in 1969?
Offer a very short reply. 1.01. What is the ratio of the Population (in %) of Macedonia in 1965 to that in 1969?
Your answer should be very brief. 1.07. What is the ratio of the Population (in %) in Finland in 1965 to that in 1970?
Your response must be concise. 1.1. What is the ratio of the Population (in %) of Guatemala in 1965 to that in 1970?
Keep it short and to the point. 1.01. What is the ratio of the Population (in %) of Macedonia in 1965 to that in 1970?
Your answer should be compact. 1.09. What is the ratio of the Population (in %) in Uganda in 1965 to that in 1970?
Keep it short and to the point. 0.99. What is the ratio of the Population (in %) in Finland in 1965 to that in 1971?
Offer a terse response. 1.13. What is the ratio of the Population (in %) of Guatemala in 1965 to that in 1971?
Offer a terse response. 1.01. What is the ratio of the Population (in %) in Macedonia in 1965 to that in 1971?
Give a very brief answer. 1.11. What is the ratio of the Population (in %) of Uganda in 1965 to that in 1971?
Your answer should be compact. 0.99. What is the ratio of the Population (in %) in Finland in 1965 to that in 1972?
Your response must be concise. 1.15. What is the ratio of the Population (in %) of Guatemala in 1965 to that in 1972?
Provide a short and direct response. 1.01. What is the ratio of the Population (in %) of Macedonia in 1965 to that in 1972?
Ensure brevity in your answer.  1.13. What is the ratio of the Population (in %) of Uganda in 1965 to that in 1972?
Offer a terse response. 0.99. What is the ratio of the Population (in %) of Finland in 1966 to that in 1967?
Ensure brevity in your answer.  1.02. What is the ratio of the Population (in %) in Guatemala in 1966 to that in 1967?
Offer a very short reply. 1. What is the ratio of the Population (in %) of Macedonia in 1966 to that in 1967?
Make the answer very short. 1.02. What is the ratio of the Population (in %) of Uganda in 1966 to that in 1967?
Offer a terse response. 1. What is the ratio of the Population (in %) of Finland in 1966 to that in 1968?
Give a very brief answer. 1.04. What is the ratio of the Population (in %) in Guatemala in 1966 to that in 1968?
Your answer should be compact. 1.01. What is the ratio of the Population (in %) of Macedonia in 1966 to that in 1968?
Ensure brevity in your answer.  1.04. What is the ratio of the Population (in %) in Uganda in 1966 to that in 1968?
Make the answer very short. 1. What is the ratio of the Population (in %) in Finland in 1966 to that in 1969?
Give a very brief answer. 1.06. What is the ratio of the Population (in %) of Guatemala in 1966 to that in 1969?
Offer a very short reply. 1.01. What is the ratio of the Population (in %) of Macedonia in 1966 to that in 1969?
Give a very brief answer. 1.06. What is the ratio of the Population (in %) in Finland in 1966 to that in 1970?
Provide a short and direct response. 1.08. What is the ratio of the Population (in %) of Guatemala in 1966 to that in 1970?
Your answer should be compact. 1.01. What is the ratio of the Population (in %) of Macedonia in 1966 to that in 1970?
Make the answer very short. 1.08. What is the ratio of the Population (in %) of Uganda in 1966 to that in 1970?
Provide a short and direct response. 1. What is the ratio of the Population (in %) of Finland in 1966 to that in 1971?
Give a very brief answer. 1.1. What is the ratio of the Population (in %) in Guatemala in 1966 to that in 1971?
Provide a succinct answer. 1.01. What is the ratio of the Population (in %) in Macedonia in 1966 to that in 1971?
Provide a short and direct response. 1.09. What is the ratio of the Population (in %) of Uganda in 1966 to that in 1971?
Offer a very short reply. 0.99. What is the ratio of the Population (in %) of Finland in 1966 to that in 1972?
Provide a short and direct response. 1.13. What is the ratio of the Population (in %) in Guatemala in 1966 to that in 1972?
Provide a short and direct response. 1.01. What is the ratio of the Population (in %) of Macedonia in 1966 to that in 1972?
Your response must be concise. 1.11. What is the ratio of the Population (in %) in Finland in 1967 to that in 1968?
Keep it short and to the point. 1.02. What is the ratio of the Population (in %) in Guatemala in 1967 to that in 1968?
Provide a short and direct response. 1. What is the ratio of the Population (in %) in Macedonia in 1967 to that in 1968?
Provide a succinct answer. 1.02. What is the ratio of the Population (in %) of Uganda in 1967 to that in 1968?
Give a very brief answer. 1. What is the ratio of the Population (in %) of Finland in 1967 to that in 1969?
Provide a short and direct response. 1.04. What is the ratio of the Population (in %) of Guatemala in 1967 to that in 1969?
Provide a short and direct response. 1.01. What is the ratio of the Population (in %) in Macedonia in 1967 to that in 1969?
Provide a succinct answer. 1.04. What is the ratio of the Population (in %) of Finland in 1967 to that in 1970?
Provide a short and direct response. 1.06. What is the ratio of the Population (in %) in Macedonia in 1967 to that in 1970?
Keep it short and to the point. 1.06. What is the ratio of the Population (in %) in Uganda in 1967 to that in 1970?
Keep it short and to the point. 1. What is the ratio of the Population (in %) of Finland in 1967 to that in 1971?
Keep it short and to the point. 1.08. What is the ratio of the Population (in %) in Guatemala in 1967 to that in 1971?
Give a very brief answer. 1.01. What is the ratio of the Population (in %) in Macedonia in 1967 to that in 1971?
Provide a succinct answer. 1.08. What is the ratio of the Population (in %) of Finland in 1967 to that in 1972?
Your answer should be very brief. 1.11. What is the ratio of the Population (in %) in Guatemala in 1967 to that in 1972?
Provide a succinct answer. 1.01. What is the ratio of the Population (in %) in Macedonia in 1967 to that in 1972?
Offer a very short reply. 1.09. What is the ratio of the Population (in %) of Uganda in 1967 to that in 1972?
Your answer should be very brief. 0.99. What is the ratio of the Population (in %) in Guatemala in 1968 to that in 1969?
Keep it short and to the point. 1. What is the ratio of the Population (in %) in Macedonia in 1968 to that in 1969?
Make the answer very short. 1.02. What is the ratio of the Population (in %) in Finland in 1968 to that in 1970?
Provide a succinct answer. 1.04. What is the ratio of the Population (in %) in Guatemala in 1968 to that in 1970?
Offer a terse response. 1.01. What is the ratio of the Population (in %) of Macedonia in 1968 to that in 1970?
Ensure brevity in your answer.  1.04. What is the ratio of the Population (in %) in Uganda in 1968 to that in 1970?
Your response must be concise. 1. What is the ratio of the Population (in %) in Finland in 1968 to that in 1971?
Your answer should be very brief. 1.06. What is the ratio of the Population (in %) of Guatemala in 1968 to that in 1971?
Keep it short and to the point. 1.01. What is the ratio of the Population (in %) in Macedonia in 1968 to that in 1971?
Provide a short and direct response. 1.06. What is the ratio of the Population (in %) of Uganda in 1968 to that in 1971?
Offer a terse response. 1. What is the ratio of the Population (in %) in Finland in 1968 to that in 1972?
Your response must be concise. 1.09. What is the ratio of the Population (in %) in Macedonia in 1968 to that in 1972?
Your answer should be compact. 1.07. What is the ratio of the Population (in %) of Uganda in 1968 to that in 1972?
Your answer should be compact. 1. What is the ratio of the Population (in %) of Finland in 1969 to that in 1970?
Keep it short and to the point. 1.02. What is the ratio of the Population (in %) in Guatemala in 1969 to that in 1970?
Your answer should be very brief. 1. What is the ratio of the Population (in %) in Macedonia in 1969 to that in 1970?
Make the answer very short. 1.02. What is the ratio of the Population (in %) in Uganda in 1969 to that in 1970?
Keep it short and to the point. 1. What is the ratio of the Population (in %) in Finland in 1969 to that in 1971?
Offer a terse response. 1.04. What is the ratio of the Population (in %) of Guatemala in 1969 to that in 1971?
Provide a succinct answer. 1. What is the ratio of the Population (in %) in Macedonia in 1969 to that in 1971?
Offer a terse response. 1.04. What is the ratio of the Population (in %) in Uganda in 1969 to that in 1971?
Your answer should be compact. 1. What is the ratio of the Population (in %) in Finland in 1969 to that in 1972?
Provide a succinct answer. 1.07. What is the ratio of the Population (in %) in Macedonia in 1969 to that in 1972?
Provide a succinct answer. 1.05. What is the ratio of the Population (in %) in Finland in 1970 to that in 1971?
Give a very brief answer. 1.02. What is the ratio of the Population (in %) in Guatemala in 1970 to that in 1971?
Ensure brevity in your answer.  1. What is the ratio of the Population (in %) of Macedonia in 1970 to that in 1971?
Offer a terse response. 1.02. What is the ratio of the Population (in %) in Uganda in 1970 to that in 1971?
Your answer should be compact. 1. What is the ratio of the Population (in %) of Finland in 1970 to that in 1972?
Make the answer very short. 1.05. What is the ratio of the Population (in %) of Macedonia in 1970 to that in 1972?
Give a very brief answer. 1.03. What is the ratio of the Population (in %) of Uganda in 1970 to that in 1972?
Offer a terse response. 0.99. What is the ratio of the Population (in %) in Finland in 1971 to that in 1972?
Give a very brief answer. 1.02. What is the ratio of the Population (in %) of Macedonia in 1971 to that in 1972?
Make the answer very short. 1.02. What is the difference between the highest and the second highest Population (in %) of Finland?
Your answer should be compact. 0.56. What is the difference between the highest and the second highest Population (in %) in Guatemala?
Offer a terse response. 0.02. What is the difference between the highest and the second highest Population (in %) of Macedonia?
Ensure brevity in your answer.  0.46. What is the difference between the highest and the second highest Population (in %) in Uganda?
Your answer should be very brief. 0.09. What is the difference between the highest and the lowest Population (in %) in Finland?
Ensure brevity in your answer.  3.64. What is the difference between the highest and the lowest Population (in %) in Guatemala?
Offer a terse response. 0.59. What is the difference between the highest and the lowest Population (in %) in Macedonia?
Make the answer very short. 4.13. What is the difference between the highest and the lowest Population (in %) in Uganda?
Keep it short and to the point. 0.54. 